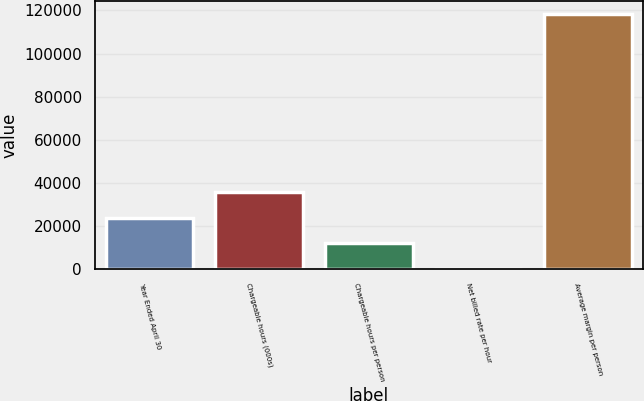Convert chart. <chart><loc_0><loc_0><loc_500><loc_500><bar_chart><fcel>Year Ended April 30<fcel>Chargeable hours (000s)<fcel>Chargeable hours per person<fcel>Net billed rate per hour<fcel>Average margin per person<nl><fcel>23801.4<fcel>35628.1<fcel>11974.7<fcel>148<fcel>118415<nl></chart> 